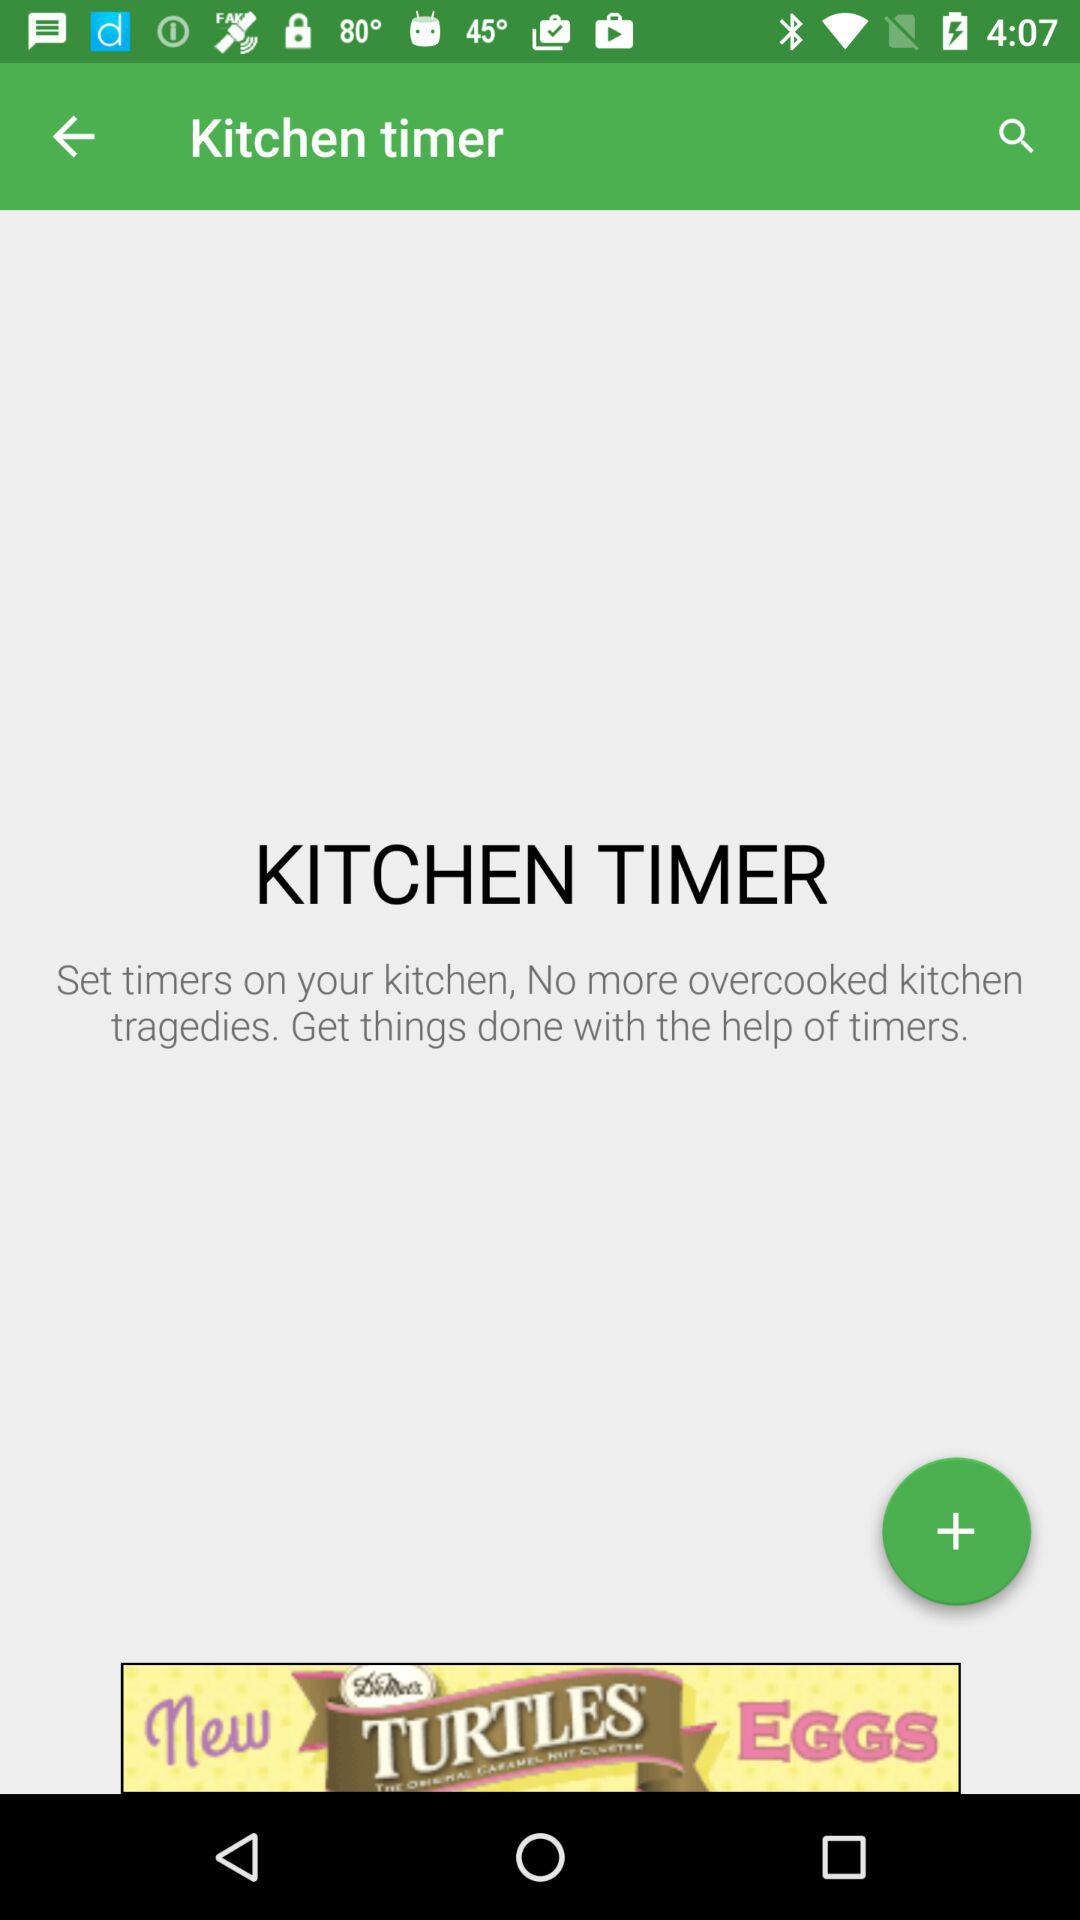What is the application name? The application name is "Kitchen timer". 